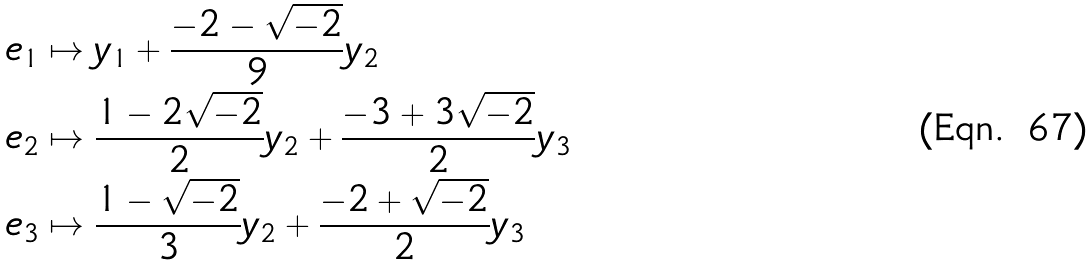<formula> <loc_0><loc_0><loc_500><loc_500>e _ { 1 } & \mapsto y _ { 1 } + \frac { - 2 - \sqrt { - 2 } } { 9 } y _ { 2 } \\ e _ { 2 } & \mapsto \frac { 1 - 2 \sqrt { - 2 } } { 2 } y _ { 2 } + \frac { - 3 + 3 \sqrt { - 2 } } { 2 } y _ { 3 } \\ e _ { 3 } & \mapsto \frac { 1 - \sqrt { - 2 } } { 3 } y _ { 2 } + \frac { - 2 + \sqrt { - 2 } } { 2 } y _ { 3 }</formula> 